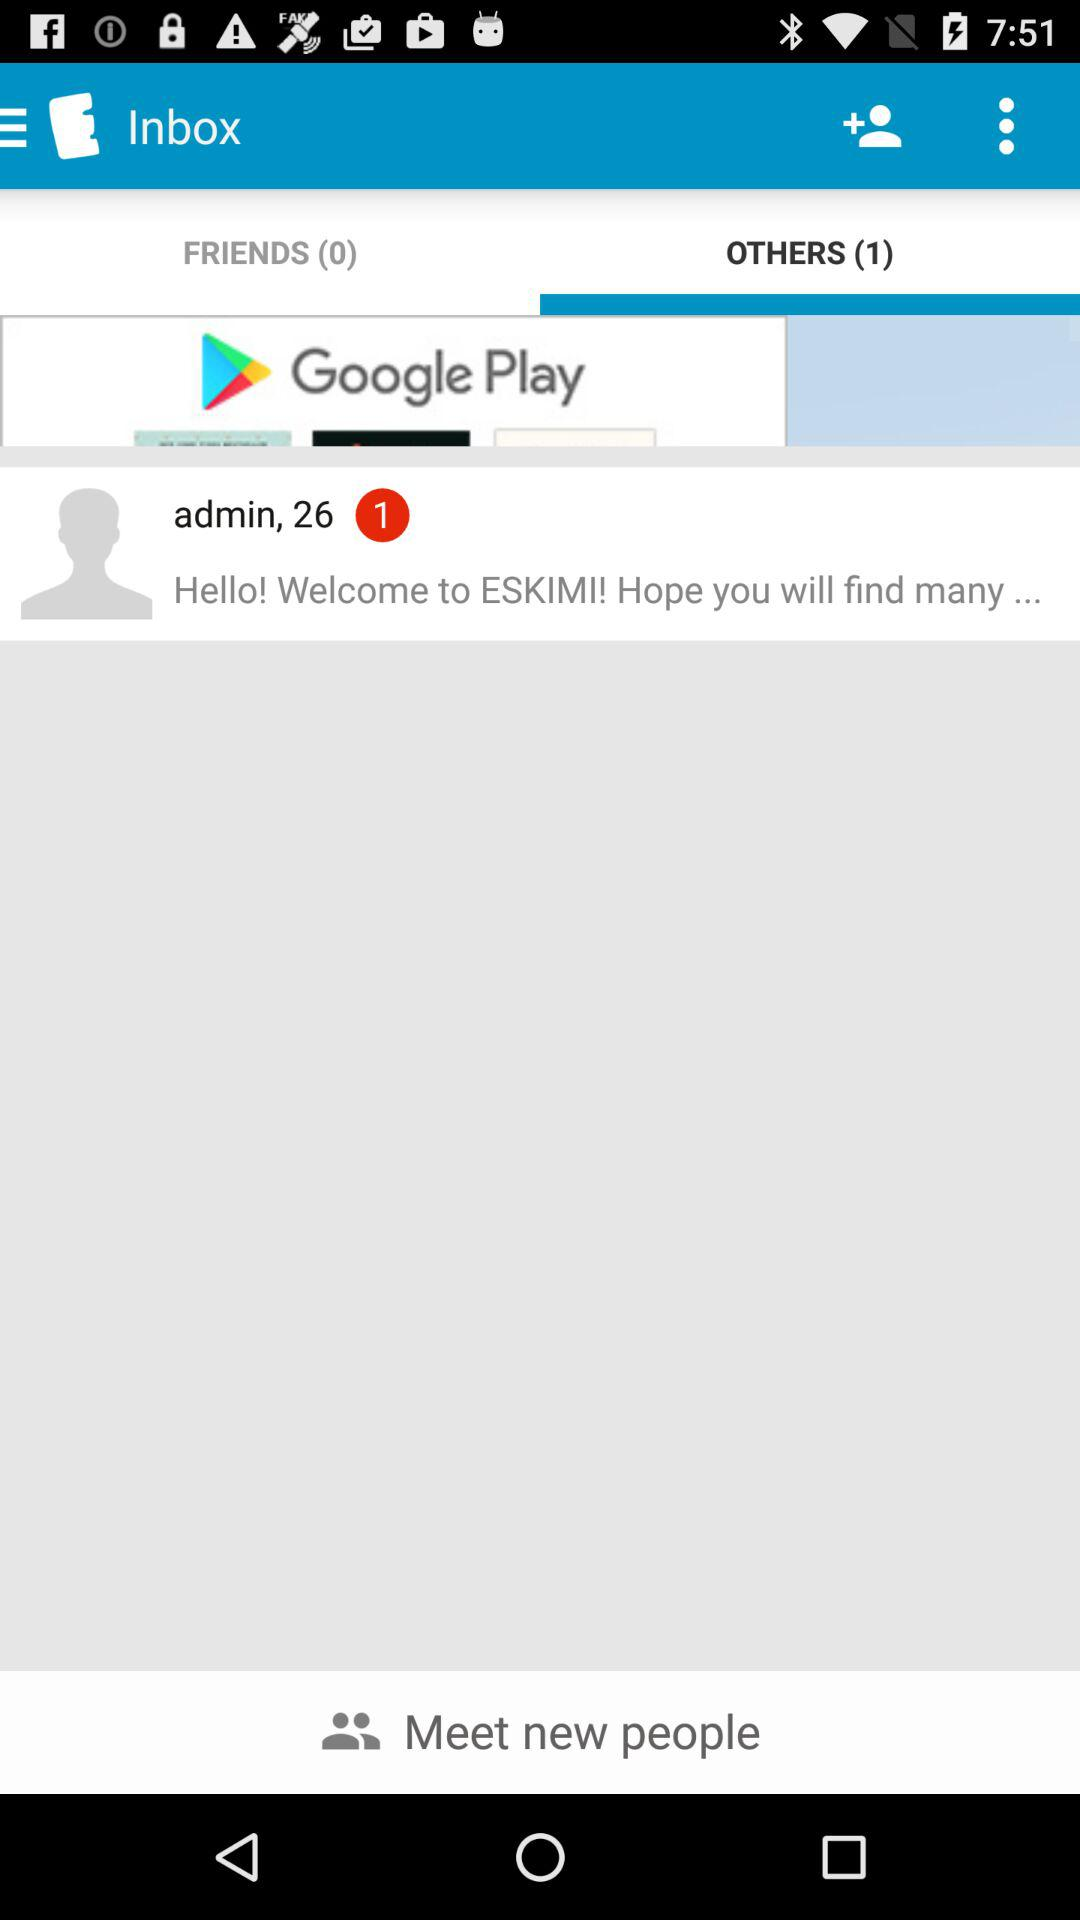What is the count of "OTHERS"? The count of "OTHERS" is 1. 